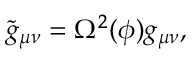Convert formula to latex. <formula><loc_0><loc_0><loc_500><loc_500>\tilde { g } _ { \mu \nu } = \Omega ^ { 2 } ( \phi ) g _ { \mu \nu } ,</formula> 